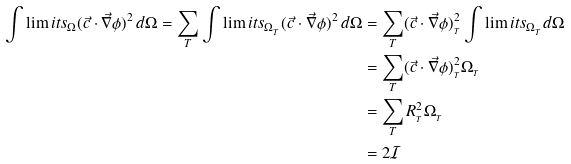<formula> <loc_0><loc_0><loc_500><loc_500>\int \lim i t s _ { \Omega } ( \vec { c } \cdot \vec { \nabla } \phi ) ^ { 2 } \, d \Omega = \sum _ { T } \int \lim i t s _ { \Omega _ { _ { T } } } ( \vec { c } \cdot \vec { \nabla } \phi ) ^ { 2 } \, d \Omega & = \sum _ { T } ( \vec { c } \cdot \vec { \nabla } \phi ) ^ { 2 } _ { _ { T } } \int \lim i t s _ { \Omega _ { _ { T } } } d \Omega \\ & = \sum _ { T } ( \vec { c } \cdot \vec { \nabla } \phi ) ^ { 2 } _ { _ { T } } \Omega _ { _ { T } } \\ & = \sum _ { T } R _ { _ { T } } ^ { 2 } \Omega _ { _ { T } } \\ & = 2 \mathcal { I }</formula> 